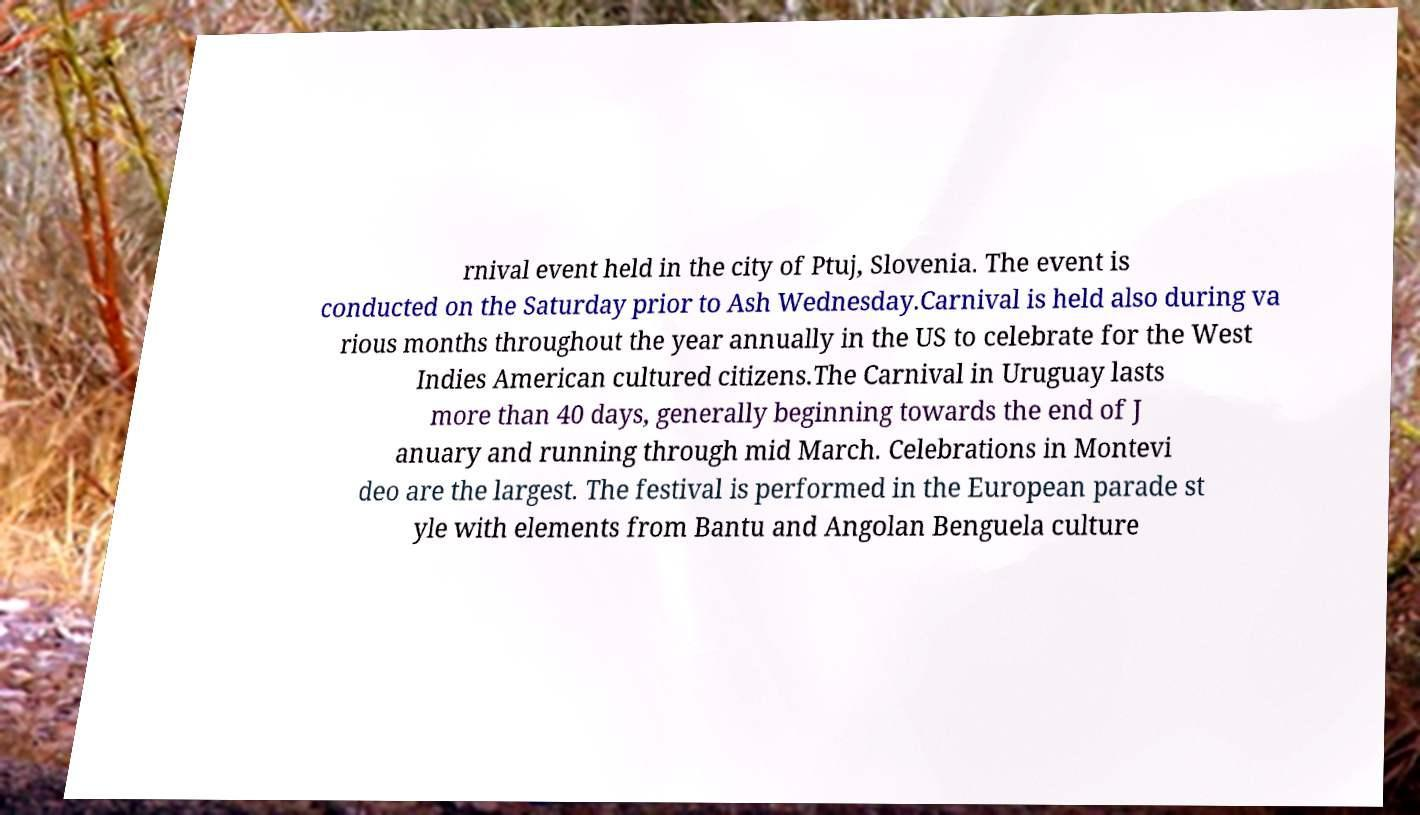Could you extract and type out the text from this image? rnival event held in the city of Ptuj, Slovenia. The event is conducted on the Saturday prior to Ash Wednesday.Carnival is held also during va rious months throughout the year annually in the US to celebrate for the West Indies American cultured citizens.The Carnival in Uruguay lasts more than 40 days, generally beginning towards the end of J anuary and running through mid March. Celebrations in Montevi deo are the largest. The festival is performed in the European parade st yle with elements from Bantu and Angolan Benguela culture 